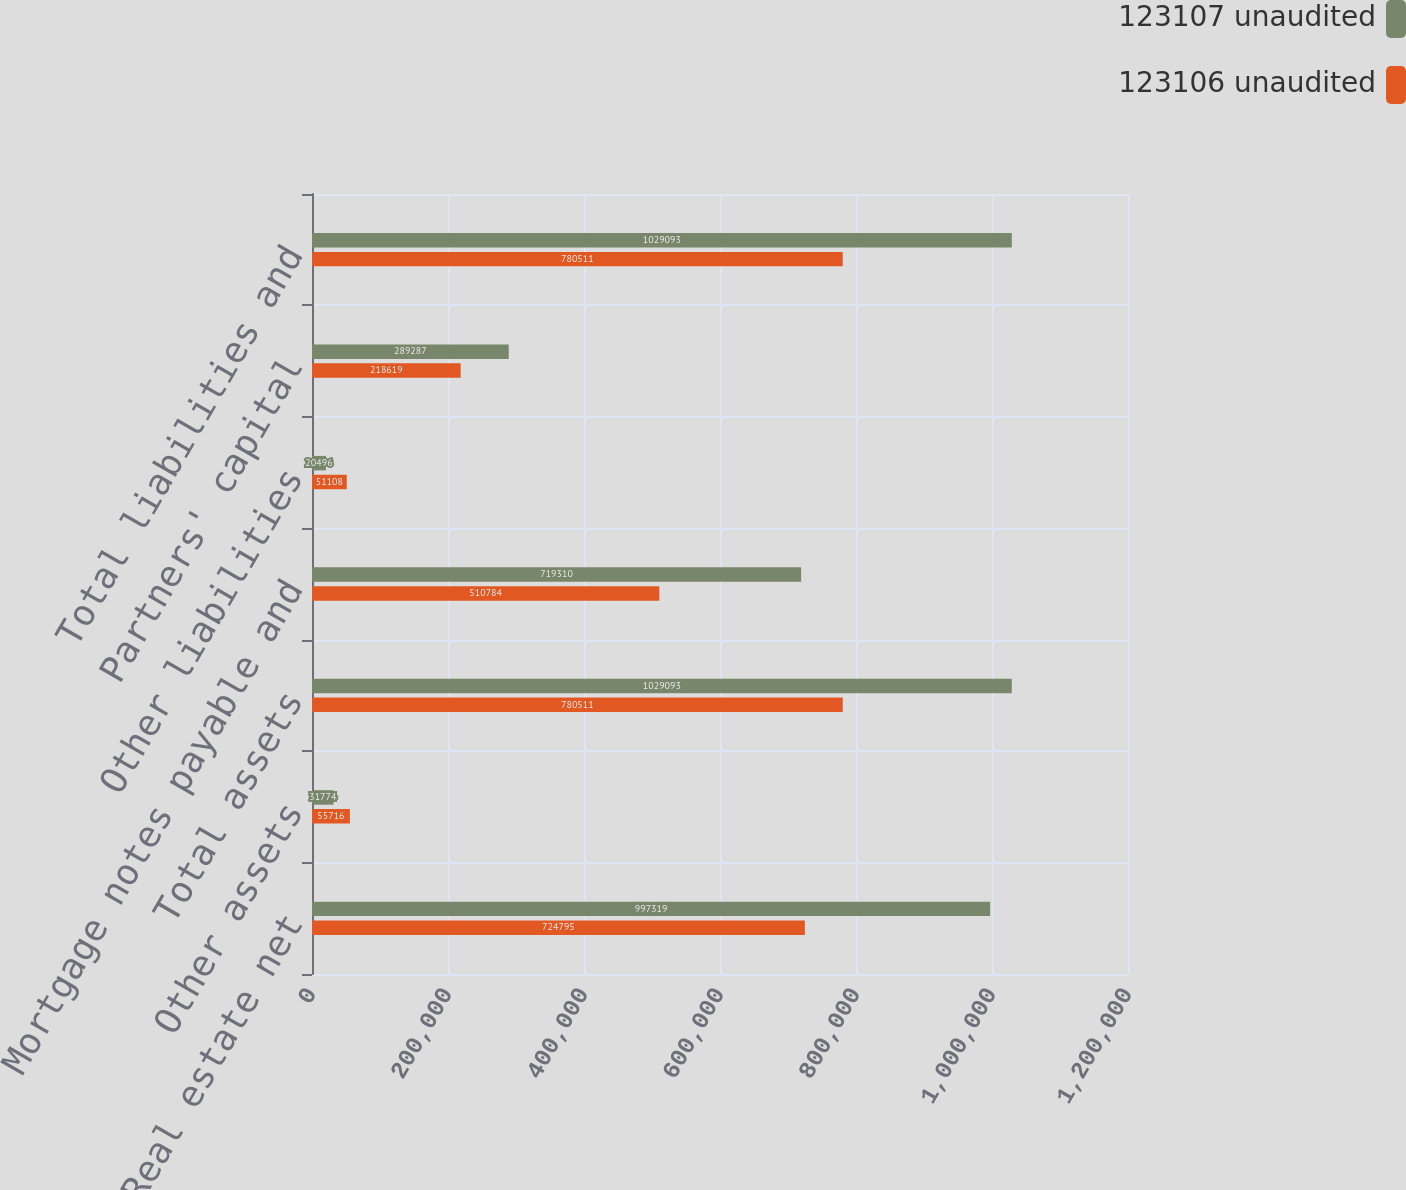<chart> <loc_0><loc_0><loc_500><loc_500><stacked_bar_chart><ecel><fcel>Real estate net<fcel>Other assets<fcel>Total assets<fcel>Mortgage notes payable and<fcel>Other liabilities<fcel>Partners' capital<fcel>Total liabilities and<nl><fcel>123107 unaudited<fcel>997319<fcel>31774<fcel>1.02909e+06<fcel>719310<fcel>20496<fcel>289287<fcel>1.02909e+06<nl><fcel>123106 unaudited<fcel>724795<fcel>55716<fcel>780511<fcel>510784<fcel>51108<fcel>218619<fcel>780511<nl></chart> 